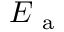<formula> <loc_0><loc_0><loc_500><loc_500>E _ { a }</formula> 